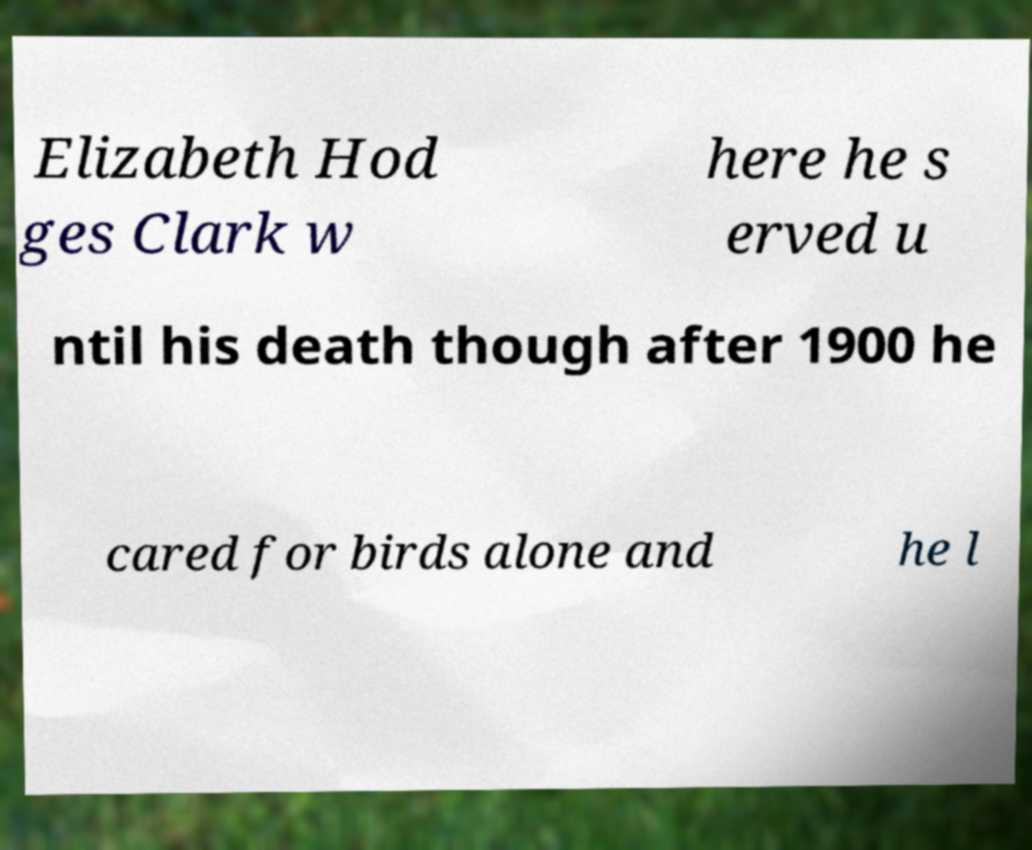What messages or text are displayed in this image? I need them in a readable, typed format. Elizabeth Hod ges Clark w here he s erved u ntil his death though after 1900 he cared for birds alone and he l 